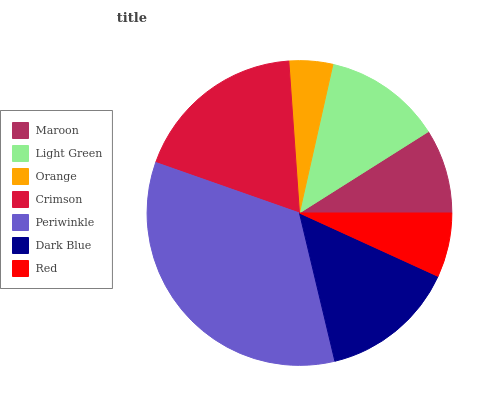Is Orange the minimum?
Answer yes or no. Yes. Is Periwinkle the maximum?
Answer yes or no. Yes. Is Light Green the minimum?
Answer yes or no. No. Is Light Green the maximum?
Answer yes or no. No. Is Light Green greater than Maroon?
Answer yes or no. Yes. Is Maroon less than Light Green?
Answer yes or no. Yes. Is Maroon greater than Light Green?
Answer yes or no. No. Is Light Green less than Maroon?
Answer yes or no. No. Is Light Green the high median?
Answer yes or no. Yes. Is Light Green the low median?
Answer yes or no. Yes. Is Crimson the high median?
Answer yes or no. No. Is Red the low median?
Answer yes or no. No. 